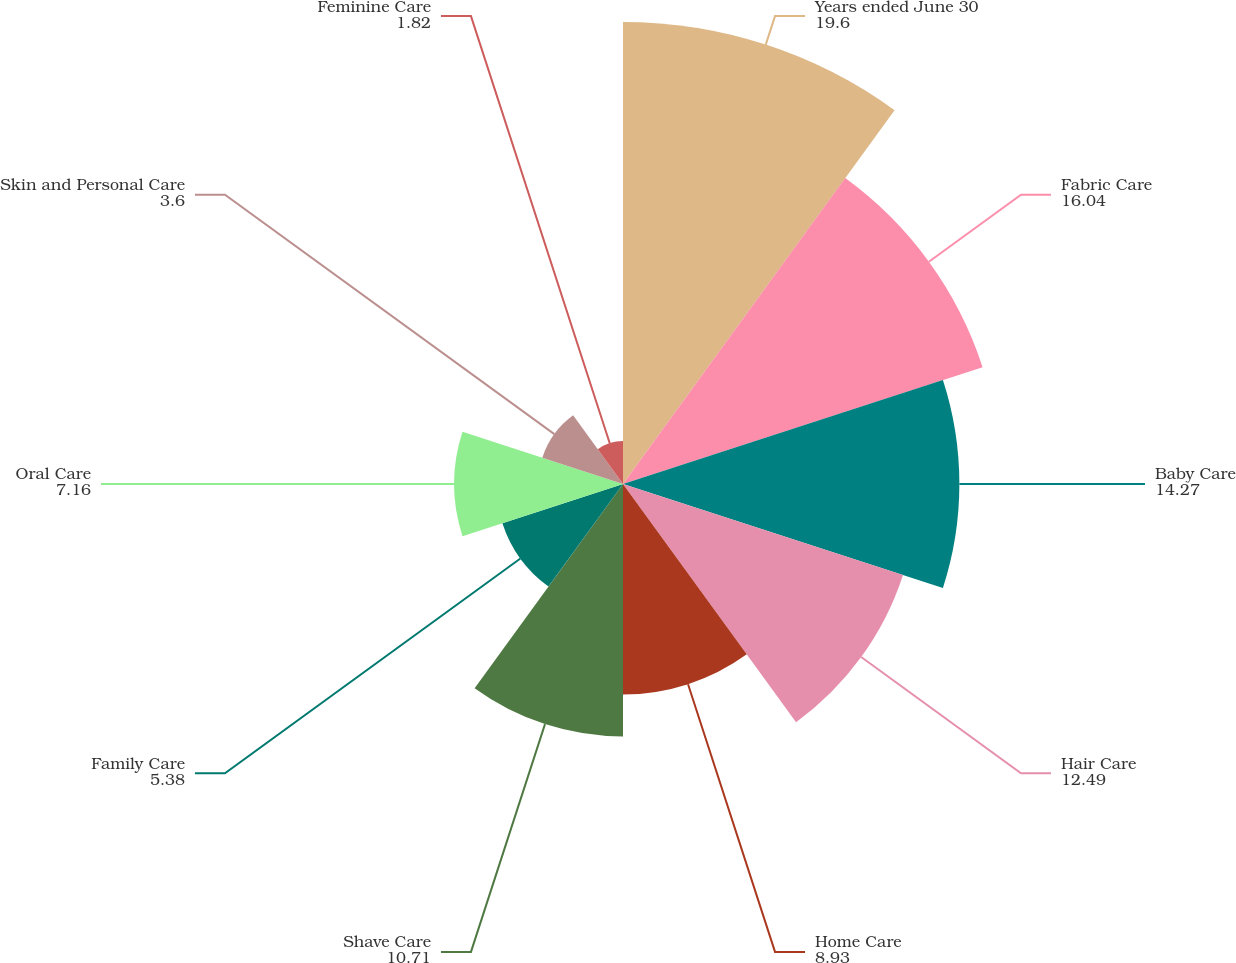Convert chart. <chart><loc_0><loc_0><loc_500><loc_500><pie_chart><fcel>Years ended June 30<fcel>Fabric Care<fcel>Baby Care<fcel>Hair Care<fcel>Home Care<fcel>Shave Care<fcel>Family Care<fcel>Oral Care<fcel>Skin and Personal Care<fcel>Feminine Care<nl><fcel>19.6%<fcel>16.04%<fcel>14.27%<fcel>12.49%<fcel>8.93%<fcel>10.71%<fcel>5.38%<fcel>7.16%<fcel>3.6%<fcel>1.82%<nl></chart> 